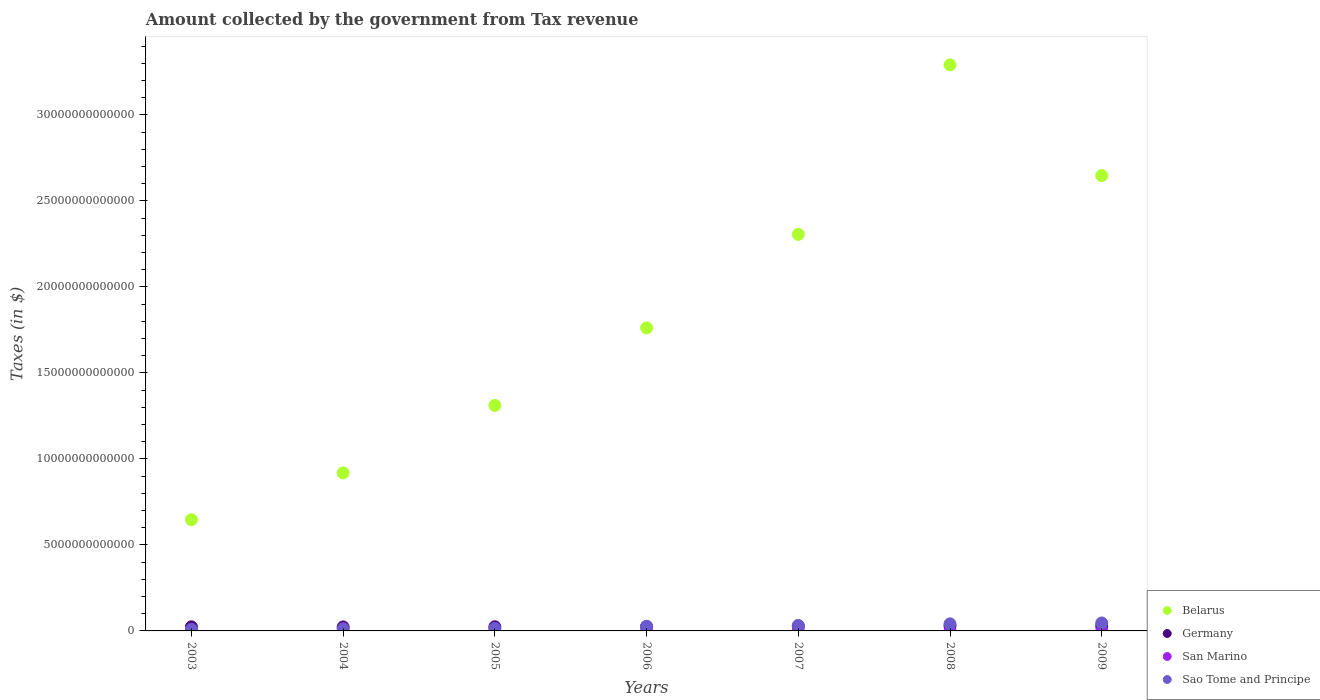How many different coloured dotlines are there?
Make the answer very short. 4. Is the number of dotlines equal to the number of legend labels?
Your response must be concise. Yes. What is the amount collected by the government from tax revenue in Germany in 2009?
Your answer should be compact. 2.82e+11. Across all years, what is the maximum amount collected by the government from tax revenue in San Marino?
Your answer should be very brief. 2.89e+08. Across all years, what is the minimum amount collected by the government from tax revenue in San Marino?
Provide a succinct answer. 2.19e+08. In which year was the amount collected by the government from tax revenue in Germany maximum?
Keep it short and to the point. 2008. What is the total amount collected by the government from tax revenue in Belarus in the graph?
Your response must be concise. 1.29e+14. What is the difference between the amount collected by the government from tax revenue in San Marino in 2004 and that in 2009?
Offer a terse response. -3.11e+07. What is the difference between the amount collected by the government from tax revenue in Belarus in 2004 and the amount collected by the government from tax revenue in San Marino in 2008?
Your answer should be compact. 9.18e+12. What is the average amount collected by the government from tax revenue in Germany per year?
Make the answer very short. 2.59e+11. In the year 2009, what is the difference between the amount collected by the government from tax revenue in Germany and amount collected by the government from tax revenue in Sao Tome and Principe?
Your answer should be very brief. -1.79e+11. In how many years, is the amount collected by the government from tax revenue in Belarus greater than 5000000000000 $?
Make the answer very short. 7. What is the ratio of the amount collected by the government from tax revenue in San Marino in 2007 to that in 2009?
Make the answer very short. 1.12. Is the difference between the amount collected by the government from tax revenue in Germany in 2008 and 2009 greater than the difference between the amount collected by the government from tax revenue in Sao Tome and Principe in 2008 and 2009?
Offer a very short reply. Yes. What is the difference between the highest and the second highest amount collected by the government from tax revenue in Germany?
Offer a very short reply. 3.58e+09. What is the difference between the highest and the lowest amount collected by the government from tax revenue in Sao Tome and Principe?
Provide a succinct answer. 3.66e+11. Is it the case that in every year, the sum of the amount collected by the government from tax revenue in Belarus and amount collected by the government from tax revenue in Sao Tome and Principe  is greater than the amount collected by the government from tax revenue in San Marino?
Your answer should be very brief. Yes. Does the amount collected by the government from tax revenue in San Marino monotonically increase over the years?
Provide a short and direct response. No. Is the amount collected by the government from tax revenue in Belarus strictly greater than the amount collected by the government from tax revenue in Sao Tome and Principe over the years?
Ensure brevity in your answer.  Yes. Is the amount collected by the government from tax revenue in Sao Tome and Principe strictly less than the amount collected by the government from tax revenue in San Marino over the years?
Ensure brevity in your answer.  No. What is the difference between two consecutive major ticks on the Y-axis?
Offer a terse response. 5.00e+12. Are the values on the major ticks of Y-axis written in scientific E-notation?
Make the answer very short. No. Does the graph contain any zero values?
Your answer should be compact. No. How many legend labels are there?
Make the answer very short. 4. What is the title of the graph?
Provide a succinct answer. Amount collected by the government from Tax revenue. What is the label or title of the X-axis?
Provide a short and direct response. Years. What is the label or title of the Y-axis?
Make the answer very short. Taxes (in $). What is the Taxes (in $) of Belarus in 2003?
Your answer should be compact. 6.47e+12. What is the Taxes (in $) of Germany in 2003?
Your answer should be compact. 2.38e+11. What is the Taxes (in $) in San Marino in 2003?
Offer a terse response. 2.19e+08. What is the Taxes (in $) of Sao Tome and Principe in 2003?
Offer a terse response. 9.57e+1. What is the Taxes (in $) in Belarus in 2004?
Provide a short and direct response. 9.18e+12. What is the Taxes (in $) in Germany in 2004?
Your response must be concise. 2.33e+11. What is the Taxes (in $) in San Marino in 2004?
Your response must be concise. 2.20e+08. What is the Taxes (in $) in Sao Tome and Principe in 2004?
Your answer should be very brief. 1.30e+11. What is the Taxes (in $) in Belarus in 2005?
Ensure brevity in your answer.  1.31e+13. What is the Taxes (in $) of Germany in 2005?
Your response must be concise. 2.40e+11. What is the Taxes (in $) in San Marino in 2005?
Give a very brief answer. 2.43e+08. What is the Taxes (in $) in Sao Tome and Principe in 2005?
Offer a terse response. 1.46e+11. What is the Taxes (in $) of Belarus in 2006?
Your answer should be very brief. 1.76e+13. What is the Taxes (in $) of Germany in 2006?
Ensure brevity in your answer.  2.55e+11. What is the Taxes (in $) in San Marino in 2006?
Offer a very short reply. 2.62e+08. What is the Taxes (in $) in Sao Tome and Principe in 2006?
Your answer should be very brief. 2.67e+11. What is the Taxes (in $) in Belarus in 2007?
Offer a terse response. 2.31e+13. What is the Taxes (in $) in Germany in 2007?
Make the answer very short. 2.79e+11. What is the Taxes (in $) in San Marino in 2007?
Make the answer very short. 2.82e+08. What is the Taxes (in $) of Sao Tome and Principe in 2007?
Give a very brief answer. 3.20e+11. What is the Taxes (in $) in Belarus in 2008?
Offer a terse response. 3.29e+13. What is the Taxes (in $) in Germany in 2008?
Your answer should be compact. 2.86e+11. What is the Taxes (in $) in San Marino in 2008?
Provide a succinct answer. 2.89e+08. What is the Taxes (in $) in Sao Tome and Principe in 2008?
Provide a succinct answer. 4.11e+11. What is the Taxes (in $) in Belarus in 2009?
Keep it short and to the point. 2.65e+13. What is the Taxes (in $) of Germany in 2009?
Your response must be concise. 2.82e+11. What is the Taxes (in $) in San Marino in 2009?
Ensure brevity in your answer.  2.51e+08. What is the Taxes (in $) of Sao Tome and Principe in 2009?
Give a very brief answer. 4.62e+11. Across all years, what is the maximum Taxes (in $) in Belarus?
Your answer should be very brief. 3.29e+13. Across all years, what is the maximum Taxes (in $) of Germany?
Your answer should be compact. 2.86e+11. Across all years, what is the maximum Taxes (in $) of San Marino?
Offer a terse response. 2.89e+08. Across all years, what is the maximum Taxes (in $) in Sao Tome and Principe?
Give a very brief answer. 4.62e+11. Across all years, what is the minimum Taxes (in $) of Belarus?
Your answer should be compact. 6.47e+12. Across all years, what is the minimum Taxes (in $) in Germany?
Keep it short and to the point. 2.33e+11. Across all years, what is the minimum Taxes (in $) of San Marino?
Make the answer very short. 2.19e+08. Across all years, what is the minimum Taxes (in $) of Sao Tome and Principe?
Keep it short and to the point. 9.57e+1. What is the total Taxes (in $) of Belarus in the graph?
Offer a very short reply. 1.29e+14. What is the total Taxes (in $) in Germany in the graph?
Give a very brief answer. 1.81e+12. What is the total Taxes (in $) of San Marino in the graph?
Your response must be concise. 1.76e+09. What is the total Taxes (in $) in Sao Tome and Principe in the graph?
Offer a very short reply. 1.83e+12. What is the difference between the Taxes (in $) of Belarus in 2003 and that in 2004?
Your response must be concise. -2.72e+12. What is the difference between the Taxes (in $) of Germany in 2003 and that in 2004?
Ensure brevity in your answer.  5.22e+09. What is the difference between the Taxes (in $) of San Marino in 2003 and that in 2004?
Give a very brief answer. -1.02e+06. What is the difference between the Taxes (in $) of Sao Tome and Principe in 2003 and that in 2004?
Keep it short and to the point. -3.42e+1. What is the difference between the Taxes (in $) of Belarus in 2003 and that in 2005?
Give a very brief answer. -6.64e+12. What is the difference between the Taxes (in $) in Germany in 2003 and that in 2005?
Your response must be concise. -2.44e+09. What is the difference between the Taxes (in $) of San Marino in 2003 and that in 2005?
Make the answer very short. -2.46e+07. What is the difference between the Taxes (in $) in Sao Tome and Principe in 2003 and that in 2005?
Provide a short and direct response. -5.02e+1. What is the difference between the Taxes (in $) in Belarus in 2003 and that in 2006?
Your response must be concise. -1.11e+13. What is the difference between the Taxes (in $) of Germany in 2003 and that in 2006?
Keep it short and to the point. -1.70e+1. What is the difference between the Taxes (in $) of San Marino in 2003 and that in 2006?
Your response must be concise. -4.34e+07. What is the difference between the Taxes (in $) of Sao Tome and Principe in 2003 and that in 2006?
Ensure brevity in your answer.  -1.71e+11. What is the difference between the Taxes (in $) of Belarus in 2003 and that in 2007?
Provide a short and direct response. -1.66e+13. What is the difference between the Taxes (in $) of Germany in 2003 and that in 2007?
Your response must be concise. -4.10e+1. What is the difference between the Taxes (in $) in San Marino in 2003 and that in 2007?
Ensure brevity in your answer.  -6.31e+07. What is the difference between the Taxes (in $) of Sao Tome and Principe in 2003 and that in 2007?
Give a very brief answer. -2.24e+11. What is the difference between the Taxes (in $) in Belarus in 2003 and that in 2008?
Offer a terse response. -2.64e+13. What is the difference between the Taxes (in $) of Germany in 2003 and that in 2008?
Offer a terse response. -4.78e+1. What is the difference between the Taxes (in $) in San Marino in 2003 and that in 2008?
Your answer should be very brief. -7.02e+07. What is the difference between the Taxes (in $) in Sao Tome and Principe in 2003 and that in 2008?
Give a very brief answer. -3.15e+11. What is the difference between the Taxes (in $) in Belarus in 2003 and that in 2009?
Make the answer very short. -2.00e+13. What is the difference between the Taxes (in $) in Germany in 2003 and that in 2009?
Your answer should be very brief. -4.42e+1. What is the difference between the Taxes (in $) in San Marino in 2003 and that in 2009?
Offer a terse response. -3.21e+07. What is the difference between the Taxes (in $) in Sao Tome and Principe in 2003 and that in 2009?
Provide a short and direct response. -3.66e+11. What is the difference between the Taxes (in $) in Belarus in 2004 and that in 2005?
Offer a very short reply. -3.93e+12. What is the difference between the Taxes (in $) in Germany in 2004 and that in 2005?
Your answer should be compact. -7.66e+09. What is the difference between the Taxes (in $) of San Marino in 2004 and that in 2005?
Your response must be concise. -2.36e+07. What is the difference between the Taxes (in $) in Sao Tome and Principe in 2004 and that in 2005?
Provide a succinct answer. -1.59e+1. What is the difference between the Taxes (in $) of Belarus in 2004 and that in 2006?
Your answer should be compact. -8.43e+12. What is the difference between the Taxes (in $) in Germany in 2004 and that in 2006?
Your answer should be compact. -2.22e+1. What is the difference between the Taxes (in $) in San Marino in 2004 and that in 2006?
Ensure brevity in your answer.  -4.23e+07. What is the difference between the Taxes (in $) of Sao Tome and Principe in 2004 and that in 2006?
Your response must be concise. -1.37e+11. What is the difference between the Taxes (in $) in Belarus in 2004 and that in 2007?
Keep it short and to the point. -1.39e+13. What is the difference between the Taxes (in $) of Germany in 2004 and that in 2007?
Keep it short and to the point. -4.62e+1. What is the difference between the Taxes (in $) of San Marino in 2004 and that in 2007?
Give a very brief answer. -6.21e+07. What is the difference between the Taxes (in $) in Sao Tome and Principe in 2004 and that in 2007?
Your response must be concise. -1.90e+11. What is the difference between the Taxes (in $) of Belarus in 2004 and that in 2008?
Ensure brevity in your answer.  -2.37e+13. What is the difference between the Taxes (in $) in Germany in 2004 and that in 2008?
Offer a terse response. -5.30e+1. What is the difference between the Taxes (in $) in San Marino in 2004 and that in 2008?
Keep it short and to the point. -6.91e+07. What is the difference between the Taxes (in $) in Sao Tome and Principe in 2004 and that in 2008?
Provide a short and direct response. -2.81e+11. What is the difference between the Taxes (in $) of Belarus in 2004 and that in 2009?
Offer a terse response. -1.73e+13. What is the difference between the Taxes (in $) of Germany in 2004 and that in 2009?
Provide a short and direct response. -4.94e+1. What is the difference between the Taxes (in $) in San Marino in 2004 and that in 2009?
Provide a succinct answer. -3.11e+07. What is the difference between the Taxes (in $) of Sao Tome and Principe in 2004 and that in 2009?
Offer a very short reply. -3.32e+11. What is the difference between the Taxes (in $) of Belarus in 2005 and that in 2006?
Ensure brevity in your answer.  -4.50e+12. What is the difference between the Taxes (in $) in Germany in 2005 and that in 2006?
Keep it short and to the point. -1.46e+1. What is the difference between the Taxes (in $) of San Marino in 2005 and that in 2006?
Ensure brevity in your answer.  -1.88e+07. What is the difference between the Taxes (in $) in Sao Tome and Principe in 2005 and that in 2006?
Offer a terse response. -1.21e+11. What is the difference between the Taxes (in $) in Belarus in 2005 and that in 2007?
Offer a terse response. -9.94e+12. What is the difference between the Taxes (in $) of Germany in 2005 and that in 2007?
Provide a short and direct response. -3.85e+1. What is the difference between the Taxes (in $) in San Marino in 2005 and that in 2007?
Offer a very short reply. -3.85e+07. What is the difference between the Taxes (in $) in Sao Tome and Principe in 2005 and that in 2007?
Make the answer very short. -1.74e+11. What is the difference between the Taxes (in $) in Belarus in 2005 and that in 2008?
Your answer should be compact. -1.98e+13. What is the difference between the Taxes (in $) in Germany in 2005 and that in 2008?
Offer a very short reply. -4.54e+1. What is the difference between the Taxes (in $) of San Marino in 2005 and that in 2008?
Your answer should be very brief. -4.56e+07. What is the difference between the Taxes (in $) of Sao Tome and Principe in 2005 and that in 2008?
Your answer should be very brief. -2.65e+11. What is the difference between the Taxes (in $) of Belarus in 2005 and that in 2009?
Offer a very short reply. -1.34e+13. What is the difference between the Taxes (in $) in Germany in 2005 and that in 2009?
Offer a very short reply. -4.18e+1. What is the difference between the Taxes (in $) of San Marino in 2005 and that in 2009?
Keep it short and to the point. -7.51e+06. What is the difference between the Taxes (in $) of Sao Tome and Principe in 2005 and that in 2009?
Your response must be concise. -3.16e+11. What is the difference between the Taxes (in $) of Belarus in 2006 and that in 2007?
Offer a very short reply. -5.44e+12. What is the difference between the Taxes (in $) in Germany in 2006 and that in 2007?
Provide a short and direct response. -2.40e+1. What is the difference between the Taxes (in $) of San Marino in 2006 and that in 2007?
Make the answer very short. -1.97e+07. What is the difference between the Taxes (in $) in Sao Tome and Principe in 2006 and that in 2007?
Keep it short and to the point. -5.32e+1. What is the difference between the Taxes (in $) of Belarus in 2006 and that in 2008?
Your answer should be very brief. -1.53e+13. What is the difference between the Taxes (in $) of Germany in 2006 and that in 2008?
Provide a succinct answer. -3.08e+1. What is the difference between the Taxes (in $) in San Marino in 2006 and that in 2008?
Offer a very short reply. -2.68e+07. What is the difference between the Taxes (in $) of Sao Tome and Principe in 2006 and that in 2008?
Your response must be concise. -1.44e+11. What is the difference between the Taxes (in $) of Belarus in 2006 and that in 2009?
Offer a very short reply. -8.86e+12. What is the difference between the Taxes (in $) of Germany in 2006 and that in 2009?
Your response must be concise. -2.72e+1. What is the difference between the Taxes (in $) in San Marino in 2006 and that in 2009?
Your answer should be compact. 1.13e+07. What is the difference between the Taxes (in $) in Sao Tome and Principe in 2006 and that in 2009?
Offer a very short reply. -1.95e+11. What is the difference between the Taxes (in $) in Belarus in 2007 and that in 2008?
Make the answer very short. -9.85e+12. What is the difference between the Taxes (in $) in Germany in 2007 and that in 2008?
Your answer should be compact. -6.81e+09. What is the difference between the Taxes (in $) of San Marino in 2007 and that in 2008?
Provide a short and direct response. -7.06e+06. What is the difference between the Taxes (in $) of Sao Tome and Principe in 2007 and that in 2008?
Offer a very short reply. -9.12e+1. What is the difference between the Taxes (in $) of Belarus in 2007 and that in 2009?
Keep it short and to the point. -3.42e+12. What is the difference between the Taxes (in $) in Germany in 2007 and that in 2009?
Make the answer very short. -3.23e+09. What is the difference between the Taxes (in $) in San Marino in 2007 and that in 2009?
Keep it short and to the point. 3.10e+07. What is the difference between the Taxes (in $) in Sao Tome and Principe in 2007 and that in 2009?
Ensure brevity in your answer.  -1.42e+11. What is the difference between the Taxes (in $) of Belarus in 2008 and that in 2009?
Your answer should be very brief. 6.44e+12. What is the difference between the Taxes (in $) in Germany in 2008 and that in 2009?
Provide a short and direct response. 3.58e+09. What is the difference between the Taxes (in $) in San Marino in 2008 and that in 2009?
Provide a short and direct response. 3.80e+07. What is the difference between the Taxes (in $) of Sao Tome and Principe in 2008 and that in 2009?
Give a very brief answer. -5.06e+1. What is the difference between the Taxes (in $) of Belarus in 2003 and the Taxes (in $) of Germany in 2004?
Offer a terse response. 6.23e+12. What is the difference between the Taxes (in $) of Belarus in 2003 and the Taxes (in $) of San Marino in 2004?
Your response must be concise. 6.47e+12. What is the difference between the Taxes (in $) of Belarus in 2003 and the Taxes (in $) of Sao Tome and Principe in 2004?
Make the answer very short. 6.34e+12. What is the difference between the Taxes (in $) of Germany in 2003 and the Taxes (in $) of San Marino in 2004?
Your response must be concise. 2.38e+11. What is the difference between the Taxes (in $) in Germany in 2003 and the Taxes (in $) in Sao Tome and Principe in 2004?
Offer a terse response. 1.08e+11. What is the difference between the Taxes (in $) of San Marino in 2003 and the Taxes (in $) of Sao Tome and Principe in 2004?
Keep it short and to the point. -1.30e+11. What is the difference between the Taxes (in $) in Belarus in 2003 and the Taxes (in $) in Germany in 2005?
Give a very brief answer. 6.23e+12. What is the difference between the Taxes (in $) in Belarus in 2003 and the Taxes (in $) in San Marino in 2005?
Your answer should be very brief. 6.47e+12. What is the difference between the Taxes (in $) of Belarus in 2003 and the Taxes (in $) of Sao Tome and Principe in 2005?
Give a very brief answer. 6.32e+12. What is the difference between the Taxes (in $) of Germany in 2003 and the Taxes (in $) of San Marino in 2005?
Provide a short and direct response. 2.38e+11. What is the difference between the Taxes (in $) in Germany in 2003 and the Taxes (in $) in Sao Tome and Principe in 2005?
Your response must be concise. 9.22e+1. What is the difference between the Taxes (in $) in San Marino in 2003 and the Taxes (in $) in Sao Tome and Principe in 2005?
Offer a very short reply. -1.46e+11. What is the difference between the Taxes (in $) in Belarus in 2003 and the Taxes (in $) in Germany in 2006?
Make the answer very short. 6.21e+12. What is the difference between the Taxes (in $) of Belarus in 2003 and the Taxes (in $) of San Marino in 2006?
Provide a short and direct response. 6.47e+12. What is the difference between the Taxes (in $) of Belarus in 2003 and the Taxes (in $) of Sao Tome and Principe in 2006?
Offer a very short reply. 6.20e+12. What is the difference between the Taxes (in $) in Germany in 2003 and the Taxes (in $) in San Marino in 2006?
Provide a succinct answer. 2.38e+11. What is the difference between the Taxes (in $) in Germany in 2003 and the Taxes (in $) in Sao Tome and Principe in 2006?
Your answer should be compact. -2.86e+1. What is the difference between the Taxes (in $) in San Marino in 2003 and the Taxes (in $) in Sao Tome and Principe in 2006?
Ensure brevity in your answer.  -2.66e+11. What is the difference between the Taxes (in $) of Belarus in 2003 and the Taxes (in $) of Germany in 2007?
Give a very brief answer. 6.19e+12. What is the difference between the Taxes (in $) in Belarus in 2003 and the Taxes (in $) in San Marino in 2007?
Provide a succinct answer. 6.47e+12. What is the difference between the Taxes (in $) of Belarus in 2003 and the Taxes (in $) of Sao Tome and Principe in 2007?
Your response must be concise. 6.15e+12. What is the difference between the Taxes (in $) of Germany in 2003 and the Taxes (in $) of San Marino in 2007?
Your answer should be compact. 2.38e+11. What is the difference between the Taxes (in $) in Germany in 2003 and the Taxes (in $) in Sao Tome and Principe in 2007?
Provide a short and direct response. -8.18e+1. What is the difference between the Taxes (in $) in San Marino in 2003 and the Taxes (in $) in Sao Tome and Principe in 2007?
Provide a succinct answer. -3.20e+11. What is the difference between the Taxes (in $) of Belarus in 2003 and the Taxes (in $) of Germany in 2008?
Provide a short and direct response. 6.18e+12. What is the difference between the Taxes (in $) of Belarus in 2003 and the Taxes (in $) of San Marino in 2008?
Your answer should be compact. 6.47e+12. What is the difference between the Taxes (in $) of Belarus in 2003 and the Taxes (in $) of Sao Tome and Principe in 2008?
Your response must be concise. 6.06e+12. What is the difference between the Taxes (in $) of Germany in 2003 and the Taxes (in $) of San Marino in 2008?
Your answer should be compact. 2.38e+11. What is the difference between the Taxes (in $) in Germany in 2003 and the Taxes (in $) in Sao Tome and Principe in 2008?
Keep it short and to the point. -1.73e+11. What is the difference between the Taxes (in $) of San Marino in 2003 and the Taxes (in $) of Sao Tome and Principe in 2008?
Keep it short and to the point. -4.11e+11. What is the difference between the Taxes (in $) of Belarus in 2003 and the Taxes (in $) of Germany in 2009?
Offer a terse response. 6.19e+12. What is the difference between the Taxes (in $) in Belarus in 2003 and the Taxes (in $) in San Marino in 2009?
Give a very brief answer. 6.47e+12. What is the difference between the Taxes (in $) of Belarus in 2003 and the Taxes (in $) of Sao Tome and Principe in 2009?
Offer a terse response. 6.01e+12. What is the difference between the Taxes (in $) in Germany in 2003 and the Taxes (in $) in San Marino in 2009?
Provide a short and direct response. 2.38e+11. What is the difference between the Taxes (in $) of Germany in 2003 and the Taxes (in $) of Sao Tome and Principe in 2009?
Provide a succinct answer. -2.24e+11. What is the difference between the Taxes (in $) of San Marino in 2003 and the Taxes (in $) of Sao Tome and Principe in 2009?
Keep it short and to the point. -4.61e+11. What is the difference between the Taxes (in $) in Belarus in 2004 and the Taxes (in $) in Germany in 2005?
Offer a very short reply. 8.94e+12. What is the difference between the Taxes (in $) in Belarus in 2004 and the Taxes (in $) in San Marino in 2005?
Provide a short and direct response. 9.18e+12. What is the difference between the Taxes (in $) in Belarus in 2004 and the Taxes (in $) in Sao Tome and Principe in 2005?
Your answer should be very brief. 9.04e+12. What is the difference between the Taxes (in $) of Germany in 2004 and the Taxes (in $) of San Marino in 2005?
Your response must be concise. 2.33e+11. What is the difference between the Taxes (in $) of Germany in 2004 and the Taxes (in $) of Sao Tome and Principe in 2005?
Your response must be concise. 8.69e+1. What is the difference between the Taxes (in $) in San Marino in 2004 and the Taxes (in $) in Sao Tome and Principe in 2005?
Ensure brevity in your answer.  -1.46e+11. What is the difference between the Taxes (in $) in Belarus in 2004 and the Taxes (in $) in Germany in 2006?
Your answer should be compact. 8.93e+12. What is the difference between the Taxes (in $) of Belarus in 2004 and the Taxes (in $) of San Marino in 2006?
Keep it short and to the point. 9.18e+12. What is the difference between the Taxes (in $) of Belarus in 2004 and the Taxes (in $) of Sao Tome and Principe in 2006?
Make the answer very short. 8.92e+12. What is the difference between the Taxes (in $) in Germany in 2004 and the Taxes (in $) in San Marino in 2006?
Offer a terse response. 2.33e+11. What is the difference between the Taxes (in $) in Germany in 2004 and the Taxes (in $) in Sao Tome and Principe in 2006?
Offer a terse response. -3.38e+1. What is the difference between the Taxes (in $) in San Marino in 2004 and the Taxes (in $) in Sao Tome and Principe in 2006?
Your answer should be compact. -2.66e+11. What is the difference between the Taxes (in $) in Belarus in 2004 and the Taxes (in $) in Germany in 2007?
Give a very brief answer. 8.91e+12. What is the difference between the Taxes (in $) in Belarus in 2004 and the Taxes (in $) in San Marino in 2007?
Your answer should be very brief. 9.18e+12. What is the difference between the Taxes (in $) of Belarus in 2004 and the Taxes (in $) of Sao Tome and Principe in 2007?
Your answer should be very brief. 8.86e+12. What is the difference between the Taxes (in $) of Germany in 2004 and the Taxes (in $) of San Marino in 2007?
Make the answer very short. 2.33e+11. What is the difference between the Taxes (in $) in Germany in 2004 and the Taxes (in $) in Sao Tome and Principe in 2007?
Your response must be concise. -8.70e+1. What is the difference between the Taxes (in $) in San Marino in 2004 and the Taxes (in $) in Sao Tome and Principe in 2007?
Offer a terse response. -3.20e+11. What is the difference between the Taxes (in $) in Belarus in 2004 and the Taxes (in $) in Germany in 2008?
Ensure brevity in your answer.  8.90e+12. What is the difference between the Taxes (in $) in Belarus in 2004 and the Taxes (in $) in San Marino in 2008?
Ensure brevity in your answer.  9.18e+12. What is the difference between the Taxes (in $) in Belarus in 2004 and the Taxes (in $) in Sao Tome and Principe in 2008?
Offer a terse response. 8.77e+12. What is the difference between the Taxes (in $) of Germany in 2004 and the Taxes (in $) of San Marino in 2008?
Provide a succinct answer. 2.33e+11. What is the difference between the Taxes (in $) in Germany in 2004 and the Taxes (in $) in Sao Tome and Principe in 2008?
Give a very brief answer. -1.78e+11. What is the difference between the Taxes (in $) in San Marino in 2004 and the Taxes (in $) in Sao Tome and Principe in 2008?
Provide a succinct answer. -4.11e+11. What is the difference between the Taxes (in $) of Belarus in 2004 and the Taxes (in $) of Germany in 2009?
Keep it short and to the point. 8.90e+12. What is the difference between the Taxes (in $) of Belarus in 2004 and the Taxes (in $) of San Marino in 2009?
Offer a terse response. 9.18e+12. What is the difference between the Taxes (in $) of Belarus in 2004 and the Taxes (in $) of Sao Tome and Principe in 2009?
Offer a very short reply. 8.72e+12. What is the difference between the Taxes (in $) of Germany in 2004 and the Taxes (in $) of San Marino in 2009?
Your answer should be very brief. 2.33e+11. What is the difference between the Taxes (in $) of Germany in 2004 and the Taxes (in $) of Sao Tome and Principe in 2009?
Ensure brevity in your answer.  -2.29e+11. What is the difference between the Taxes (in $) of San Marino in 2004 and the Taxes (in $) of Sao Tome and Principe in 2009?
Ensure brevity in your answer.  -4.61e+11. What is the difference between the Taxes (in $) of Belarus in 2005 and the Taxes (in $) of Germany in 2006?
Provide a succinct answer. 1.29e+13. What is the difference between the Taxes (in $) in Belarus in 2005 and the Taxes (in $) in San Marino in 2006?
Offer a very short reply. 1.31e+13. What is the difference between the Taxes (in $) of Belarus in 2005 and the Taxes (in $) of Sao Tome and Principe in 2006?
Give a very brief answer. 1.28e+13. What is the difference between the Taxes (in $) of Germany in 2005 and the Taxes (in $) of San Marino in 2006?
Keep it short and to the point. 2.40e+11. What is the difference between the Taxes (in $) of Germany in 2005 and the Taxes (in $) of Sao Tome and Principe in 2006?
Provide a short and direct response. -2.62e+1. What is the difference between the Taxes (in $) of San Marino in 2005 and the Taxes (in $) of Sao Tome and Principe in 2006?
Your answer should be compact. -2.66e+11. What is the difference between the Taxes (in $) of Belarus in 2005 and the Taxes (in $) of Germany in 2007?
Your response must be concise. 1.28e+13. What is the difference between the Taxes (in $) of Belarus in 2005 and the Taxes (in $) of San Marino in 2007?
Give a very brief answer. 1.31e+13. What is the difference between the Taxes (in $) of Belarus in 2005 and the Taxes (in $) of Sao Tome and Principe in 2007?
Provide a succinct answer. 1.28e+13. What is the difference between the Taxes (in $) in Germany in 2005 and the Taxes (in $) in San Marino in 2007?
Keep it short and to the point. 2.40e+11. What is the difference between the Taxes (in $) in Germany in 2005 and the Taxes (in $) in Sao Tome and Principe in 2007?
Make the answer very short. -7.93e+1. What is the difference between the Taxes (in $) of San Marino in 2005 and the Taxes (in $) of Sao Tome and Principe in 2007?
Offer a very short reply. -3.20e+11. What is the difference between the Taxes (in $) in Belarus in 2005 and the Taxes (in $) in Germany in 2008?
Ensure brevity in your answer.  1.28e+13. What is the difference between the Taxes (in $) of Belarus in 2005 and the Taxes (in $) of San Marino in 2008?
Keep it short and to the point. 1.31e+13. What is the difference between the Taxes (in $) of Belarus in 2005 and the Taxes (in $) of Sao Tome and Principe in 2008?
Your response must be concise. 1.27e+13. What is the difference between the Taxes (in $) in Germany in 2005 and the Taxes (in $) in San Marino in 2008?
Make the answer very short. 2.40e+11. What is the difference between the Taxes (in $) in Germany in 2005 and the Taxes (in $) in Sao Tome and Principe in 2008?
Your answer should be very brief. -1.71e+11. What is the difference between the Taxes (in $) in San Marino in 2005 and the Taxes (in $) in Sao Tome and Principe in 2008?
Provide a short and direct response. -4.11e+11. What is the difference between the Taxes (in $) of Belarus in 2005 and the Taxes (in $) of Germany in 2009?
Provide a short and direct response. 1.28e+13. What is the difference between the Taxes (in $) of Belarus in 2005 and the Taxes (in $) of San Marino in 2009?
Offer a very short reply. 1.31e+13. What is the difference between the Taxes (in $) in Belarus in 2005 and the Taxes (in $) in Sao Tome and Principe in 2009?
Ensure brevity in your answer.  1.26e+13. What is the difference between the Taxes (in $) of Germany in 2005 and the Taxes (in $) of San Marino in 2009?
Give a very brief answer. 2.40e+11. What is the difference between the Taxes (in $) of Germany in 2005 and the Taxes (in $) of Sao Tome and Principe in 2009?
Your answer should be very brief. -2.21e+11. What is the difference between the Taxes (in $) of San Marino in 2005 and the Taxes (in $) of Sao Tome and Principe in 2009?
Your response must be concise. -4.61e+11. What is the difference between the Taxes (in $) in Belarus in 2006 and the Taxes (in $) in Germany in 2007?
Ensure brevity in your answer.  1.73e+13. What is the difference between the Taxes (in $) in Belarus in 2006 and the Taxes (in $) in San Marino in 2007?
Ensure brevity in your answer.  1.76e+13. What is the difference between the Taxes (in $) of Belarus in 2006 and the Taxes (in $) of Sao Tome and Principe in 2007?
Offer a terse response. 1.73e+13. What is the difference between the Taxes (in $) in Germany in 2006 and the Taxes (in $) in San Marino in 2007?
Your answer should be very brief. 2.55e+11. What is the difference between the Taxes (in $) in Germany in 2006 and the Taxes (in $) in Sao Tome and Principe in 2007?
Your answer should be very brief. -6.47e+1. What is the difference between the Taxes (in $) of San Marino in 2006 and the Taxes (in $) of Sao Tome and Principe in 2007?
Your answer should be very brief. -3.20e+11. What is the difference between the Taxes (in $) of Belarus in 2006 and the Taxes (in $) of Germany in 2008?
Your answer should be compact. 1.73e+13. What is the difference between the Taxes (in $) of Belarus in 2006 and the Taxes (in $) of San Marino in 2008?
Your answer should be compact. 1.76e+13. What is the difference between the Taxes (in $) of Belarus in 2006 and the Taxes (in $) of Sao Tome and Principe in 2008?
Offer a terse response. 1.72e+13. What is the difference between the Taxes (in $) of Germany in 2006 and the Taxes (in $) of San Marino in 2008?
Your answer should be compact. 2.55e+11. What is the difference between the Taxes (in $) of Germany in 2006 and the Taxes (in $) of Sao Tome and Principe in 2008?
Offer a terse response. -1.56e+11. What is the difference between the Taxes (in $) in San Marino in 2006 and the Taxes (in $) in Sao Tome and Principe in 2008?
Offer a very short reply. -4.11e+11. What is the difference between the Taxes (in $) of Belarus in 2006 and the Taxes (in $) of Germany in 2009?
Your answer should be very brief. 1.73e+13. What is the difference between the Taxes (in $) of Belarus in 2006 and the Taxes (in $) of San Marino in 2009?
Your answer should be very brief. 1.76e+13. What is the difference between the Taxes (in $) in Belarus in 2006 and the Taxes (in $) in Sao Tome and Principe in 2009?
Your response must be concise. 1.72e+13. What is the difference between the Taxes (in $) in Germany in 2006 and the Taxes (in $) in San Marino in 2009?
Make the answer very short. 2.55e+11. What is the difference between the Taxes (in $) in Germany in 2006 and the Taxes (in $) in Sao Tome and Principe in 2009?
Your answer should be compact. -2.07e+11. What is the difference between the Taxes (in $) in San Marino in 2006 and the Taxes (in $) in Sao Tome and Principe in 2009?
Keep it short and to the point. -4.61e+11. What is the difference between the Taxes (in $) in Belarus in 2007 and the Taxes (in $) in Germany in 2008?
Keep it short and to the point. 2.28e+13. What is the difference between the Taxes (in $) of Belarus in 2007 and the Taxes (in $) of San Marino in 2008?
Provide a short and direct response. 2.31e+13. What is the difference between the Taxes (in $) of Belarus in 2007 and the Taxes (in $) of Sao Tome and Principe in 2008?
Ensure brevity in your answer.  2.26e+13. What is the difference between the Taxes (in $) of Germany in 2007 and the Taxes (in $) of San Marino in 2008?
Your answer should be compact. 2.79e+11. What is the difference between the Taxes (in $) in Germany in 2007 and the Taxes (in $) in Sao Tome and Principe in 2008?
Ensure brevity in your answer.  -1.32e+11. What is the difference between the Taxes (in $) in San Marino in 2007 and the Taxes (in $) in Sao Tome and Principe in 2008?
Ensure brevity in your answer.  -4.11e+11. What is the difference between the Taxes (in $) of Belarus in 2007 and the Taxes (in $) of Germany in 2009?
Give a very brief answer. 2.28e+13. What is the difference between the Taxes (in $) of Belarus in 2007 and the Taxes (in $) of San Marino in 2009?
Make the answer very short. 2.31e+13. What is the difference between the Taxes (in $) in Belarus in 2007 and the Taxes (in $) in Sao Tome and Principe in 2009?
Offer a very short reply. 2.26e+13. What is the difference between the Taxes (in $) in Germany in 2007 and the Taxes (in $) in San Marino in 2009?
Give a very brief answer. 2.79e+11. What is the difference between the Taxes (in $) of Germany in 2007 and the Taxes (in $) of Sao Tome and Principe in 2009?
Your answer should be compact. -1.83e+11. What is the difference between the Taxes (in $) in San Marino in 2007 and the Taxes (in $) in Sao Tome and Principe in 2009?
Your answer should be very brief. -4.61e+11. What is the difference between the Taxes (in $) of Belarus in 2008 and the Taxes (in $) of Germany in 2009?
Offer a terse response. 3.26e+13. What is the difference between the Taxes (in $) of Belarus in 2008 and the Taxes (in $) of San Marino in 2009?
Keep it short and to the point. 3.29e+13. What is the difference between the Taxes (in $) of Belarus in 2008 and the Taxes (in $) of Sao Tome and Principe in 2009?
Make the answer very short. 3.24e+13. What is the difference between the Taxes (in $) of Germany in 2008 and the Taxes (in $) of San Marino in 2009?
Provide a succinct answer. 2.86e+11. What is the difference between the Taxes (in $) of Germany in 2008 and the Taxes (in $) of Sao Tome and Principe in 2009?
Your answer should be compact. -1.76e+11. What is the difference between the Taxes (in $) in San Marino in 2008 and the Taxes (in $) in Sao Tome and Principe in 2009?
Give a very brief answer. -4.61e+11. What is the average Taxes (in $) of Belarus per year?
Offer a terse response. 1.84e+13. What is the average Taxes (in $) of Germany per year?
Your answer should be compact. 2.59e+11. What is the average Taxes (in $) in San Marino per year?
Your answer should be compact. 2.52e+08. What is the average Taxes (in $) in Sao Tome and Principe per year?
Give a very brief answer. 2.61e+11. In the year 2003, what is the difference between the Taxes (in $) in Belarus and Taxes (in $) in Germany?
Keep it short and to the point. 6.23e+12. In the year 2003, what is the difference between the Taxes (in $) in Belarus and Taxes (in $) in San Marino?
Your answer should be compact. 6.47e+12. In the year 2003, what is the difference between the Taxes (in $) of Belarus and Taxes (in $) of Sao Tome and Principe?
Provide a succinct answer. 6.37e+12. In the year 2003, what is the difference between the Taxes (in $) of Germany and Taxes (in $) of San Marino?
Your response must be concise. 2.38e+11. In the year 2003, what is the difference between the Taxes (in $) of Germany and Taxes (in $) of Sao Tome and Principe?
Provide a succinct answer. 1.42e+11. In the year 2003, what is the difference between the Taxes (in $) in San Marino and Taxes (in $) in Sao Tome and Principe?
Provide a succinct answer. -9.55e+1. In the year 2004, what is the difference between the Taxes (in $) in Belarus and Taxes (in $) in Germany?
Offer a terse response. 8.95e+12. In the year 2004, what is the difference between the Taxes (in $) of Belarus and Taxes (in $) of San Marino?
Ensure brevity in your answer.  9.18e+12. In the year 2004, what is the difference between the Taxes (in $) in Belarus and Taxes (in $) in Sao Tome and Principe?
Your answer should be very brief. 9.05e+12. In the year 2004, what is the difference between the Taxes (in $) in Germany and Taxes (in $) in San Marino?
Offer a very short reply. 2.33e+11. In the year 2004, what is the difference between the Taxes (in $) in Germany and Taxes (in $) in Sao Tome and Principe?
Offer a very short reply. 1.03e+11. In the year 2004, what is the difference between the Taxes (in $) of San Marino and Taxes (in $) of Sao Tome and Principe?
Provide a succinct answer. -1.30e+11. In the year 2005, what is the difference between the Taxes (in $) in Belarus and Taxes (in $) in Germany?
Provide a short and direct response. 1.29e+13. In the year 2005, what is the difference between the Taxes (in $) in Belarus and Taxes (in $) in San Marino?
Your response must be concise. 1.31e+13. In the year 2005, what is the difference between the Taxes (in $) of Belarus and Taxes (in $) of Sao Tome and Principe?
Your answer should be very brief. 1.30e+13. In the year 2005, what is the difference between the Taxes (in $) in Germany and Taxes (in $) in San Marino?
Give a very brief answer. 2.40e+11. In the year 2005, what is the difference between the Taxes (in $) of Germany and Taxes (in $) of Sao Tome and Principe?
Keep it short and to the point. 9.46e+1. In the year 2005, what is the difference between the Taxes (in $) in San Marino and Taxes (in $) in Sao Tome and Principe?
Keep it short and to the point. -1.46e+11. In the year 2006, what is the difference between the Taxes (in $) in Belarus and Taxes (in $) in Germany?
Give a very brief answer. 1.74e+13. In the year 2006, what is the difference between the Taxes (in $) of Belarus and Taxes (in $) of San Marino?
Your answer should be compact. 1.76e+13. In the year 2006, what is the difference between the Taxes (in $) of Belarus and Taxes (in $) of Sao Tome and Principe?
Give a very brief answer. 1.73e+13. In the year 2006, what is the difference between the Taxes (in $) in Germany and Taxes (in $) in San Marino?
Offer a very short reply. 2.55e+11. In the year 2006, what is the difference between the Taxes (in $) of Germany and Taxes (in $) of Sao Tome and Principe?
Offer a very short reply. -1.16e+1. In the year 2006, what is the difference between the Taxes (in $) of San Marino and Taxes (in $) of Sao Tome and Principe?
Provide a succinct answer. -2.66e+11. In the year 2007, what is the difference between the Taxes (in $) in Belarus and Taxes (in $) in Germany?
Offer a terse response. 2.28e+13. In the year 2007, what is the difference between the Taxes (in $) in Belarus and Taxes (in $) in San Marino?
Ensure brevity in your answer.  2.31e+13. In the year 2007, what is the difference between the Taxes (in $) in Belarus and Taxes (in $) in Sao Tome and Principe?
Keep it short and to the point. 2.27e+13. In the year 2007, what is the difference between the Taxes (in $) of Germany and Taxes (in $) of San Marino?
Keep it short and to the point. 2.79e+11. In the year 2007, what is the difference between the Taxes (in $) of Germany and Taxes (in $) of Sao Tome and Principe?
Ensure brevity in your answer.  -4.08e+1. In the year 2007, what is the difference between the Taxes (in $) in San Marino and Taxes (in $) in Sao Tome and Principe?
Your answer should be very brief. -3.19e+11. In the year 2008, what is the difference between the Taxes (in $) of Belarus and Taxes (in $) of Germany?
Provide a succinct answer. 3.26e+13. In the year 2008, what is the difference between the Taxes (in $) of Belarus and Taxes (in $) of San Marino?
Keep it short and to the point. 3.29e+13. In the year 2008, what is the difference between the Taxes (in $) of Belarus and Taxes (in $) of Sao Tome and Principe?
Ensure brevity in your answer.  3.25e+13. In the year 2008, what is the difference between the Taxes (in $) of Germany and Taxes (in $) of San Marino?
Provide a succinct answer. 2.86e+11. In the year 2008, what is the difference between the Taxes (in $) in Germany and Taxes (in $) in Sao Tome and Principe?
Make the answer very short. -1.25e+11. In the year 2008, what is the difference between the Taxes (in $) in San Marino and Taxes (in $) in Sao Tome and Principe?
Your response must be concise. -4.11e+11. In the year 2009, what is the difference between the Taxes (in $) of Belarus and Taxes (in $) of Germany?
Your response must be concise. 2.62e+13. In the year 2009, what is the difference between the Taxes (in $) in Belarus and Taxes (in $) in San Marino?
Your response must be concise. 2.65e+13. In the year 2009, what is the difference between the Taxes (in $) in Belarus and Taxes (in $) in Sao Tome and Principe?
Provide a short and direct response. 2.60e+13. In the year 2009, what is the difference between the Taxes (in $) of Germany and Taxes (in $) of San Marino?
Your answer should be very brief. 2.82e+11. In the year 2009, what is the difference between the Taxes (in $) in Germany and Taxes (in $) in Sao Tome and Principe?
Provide a short and direct response. -1.79e+11. In the year 2009, what is the difference between the Taxes (in $) of San Marino and Taxes (in $) of Sao Tome and Principe?
Offer a very short reply. -4.61e+11. What is the ratio of the Taxes (in $) of Belarus in 2003 to that in 2004?
Your answer should be very brief. 0.7. What is the ratio of the Taxes (in $) in Germany in 2003 to that in 2004?
Ensure brevity in your answer.  1.02. What is the ratio of the Taxes (in $) of San Marino in 2003 to that in 2004?
Offer a terse response. 1. What is the ratio of the Taxes (in $) in Sao Tome and Principe in 2003 to that in 2004?
Provide a short and direct response. 0.74. What is the ratio of the Taxes (in $) in Belarus in 2003 to that in 2005?
Give a very brief answer. 0.49. What is the ratio of the Taxes (in $) of San Marino in 2003 to that in 2005?
Ensure brevity in your answer.  0.9. What is the ratio of the Taxes (in $) in Sao Tome and Principe in 2003 to that in 2005?
Offer a very short reply. 0.66. What is the ratio of the Taxes (in $) of Belarus in 2003 to that in 2006?
Your answer should be very brief. 0.37. What is the ratio of the Taxes (in $) in Germany in 2003 to that in 2006?
Your response must be concise. 0.93. What is the ratio of the Taxes (in $) of San Marino in 2003 to that in 2006?
Your answer should be compact. 0.83. What is the ratio of the Taxes (in $) in Sao Tome and Principe in 2003 to that in 2006?
Provide a short and direct response. 0.36. What is the ratio of the Taxes (in $) in Belarus in 2003 to that in 2007?
Ensure brevity in your answer.  0.28. What is the ratio of the Taxes (in $) in Germany in 2003 to that in 2007?
Offer a terse response. 0.85. What is the ratio of the Taxes (in $) in San Marino in 2003 to that in 2007?
Ensure brevity in your answer.  0.78. What is the ratio of the Taxes (in $) in Sao Tome and Principe in 2003 to that in 2007?
Offer a very short reply. 0.3. What is the ratio of the Taxes (in $) of Belarus in 2003 to that in 2008?
Offer a very short reply. 0.2. What is the ratio of the Taxes (in $) in Germany in 2003 to that in 2008?
Offer a terse response. 0.83. What is the ratio of the Taxes (in $) of San Marino in 2003 to that in 2008?
Ensure brevity in your answer.  0.76. What is the ratio of the Taxes (in $) in Sao Tome and Principe in 2003 to that in 2008?
Offer a terse response. 0.23. What is the ratio of the Taxes (in $) of Belarus in 2003 to that in 2009?
Make the answer very short. 0.24. What is the ratio of the Taxes (in $) of Germany in 2003 to that in 2009?
Offer a very short reply. 0.84. What is the ratio of the Taxes (in $) of San Marino in 2003 to that in 2009?
Your answer should be very brief. 0.87. What is the ratio of the Taxes (in $) in Sao Tome and Principe in 2003 to that in 2009?
Offer a terse response. 0.21. What is the ratio of the Taxes (in $) of Belarus in 2004 to that in 2005?
Give a very brief answer. 0.7. What is the ratio of the Taxes (in $) of Germany in 2004 to that in 2005?
Your answer should be very brief. 0.97. What is the ratio of the Taxes (in $) of San Marino in 2004 to that in 2005?
Keep it short and to the point. 0.9. What is the ratio of the Taxes (in $) in Sao Tome and Principe in 2004 to that in 2005?
Keep it short and to the point. 0.89. What is the ratio of the Taxes (in $) of Belarus in 2004 to that in 2006?
Give a very brief answer. 0.52. What is the ratio of the Taxes (in $) of Germany in 2004 to that in 2006?
Offer a very short reply. 0.91. What is the ratio of the Taxes (in $) of San Marino in 2004 to that in 2006?
Make the answer very short. 0.84. What is the ratio of the Taxes (in $) of Sao Tome and Principe in 2004 to that in 2006?
Provide a succinct answer. 0.49. What is the ratio of the Taxes (in $) in Belarus in 2004 to that in 2007?
Your answer should be compact. 0.4. What is the ratio of the Taxes (in $) in Germany in 2004 to that in 2007?
Your response must be concise. 0.83. What is the ratio of the Taxes (in $) of San Marino in 2004 to that in 2007?
Offer a terse response. 0.78. What is the ratio of the Taxes (in $) in Sao Tome and Principe in 2004 to that in 2007?
Your answer should be very brief. 0.41. What is the ratio of the Taxes (in $) in Belarus in 2004 to that in 2008?
Offer a very short reply. 0.28. What is the ratio of the Taxes (in $) in Germany in 2004 to that in 2008?
Make the answer very short. 0.81. What is the ratio of the Taxes (in $) in San Marino in 2004 to that in 2008?
Offer a very short reply. 0.76. What is the ratio of the Taxes (in $) in Sao Tome and Principe in 2004 to that in 2008?
Offer a terse response. 0.32. What is the ratio of the Taxes (in $) of Belarus in 2004 to that in 2009?
Your answer should be compact. 0.35. What is the ratio of the Taxes (in $) in Germany in 2004 to that in 2009?
Make the answer very short. 0.82. What is the ratio of the Taxes (in $) in San Marino in 2004 to that in 2009?
Provide a short and direct response. 0.88. What is the ratio of the Taxes (in $) in Sao Tome and Principe in 2004 to that in 2009?
Offer a very short reply. 0.28. What is the ratio of the Taxes (in $) in Belarus in 2005 to that in 2006?
Your answer should be very brief. 0.74. What is the ratio of the Taxes (in $) of Germany in 2005 to that in 2006?
Offer a terse response. 0.94. What is the ratio of the Taxes (in $) in San Marino in 2005 to that in 2006?
Ensure brevity in your answer.  0.93. What is the ratio of the Taxes (in $) of Sao Tome and Principe in 2005 to that in 2006?
Offer a very short reply. 0.55. What is the ratio of the Taxes (in $) of Belarus in 2005 to that in 2007?
Offer a very short reply. 0.57. What is the ratio of the Taxes (in $) of Germany in 2005 to that in 2007?
Your response must be concise. 0.86. What is the ratio of the Taxes (in $) in San Marino in 2005 to that in 2007?
Provide a short and direct response. 0.86. What is the ratio of the Taxes (in $) of Sao Tome and Principe in 2005 to that in 2007?
Make the answer very short. 0.46. What is the ratio of the Taxes (in $) in Belarus in 2005 to that in 2008?
Offer a terse response. 0.4. What is the ratio of the Taxes (in $) in Germany in 2005 to that in 2008?
Keep it short and to the point. 0.84. What is the ratio of the Taxes (in $) in San Marino in 2005 to that in 2008?
Keep it short and to the point. 0.84. What is the ratio of the Taxes (in $) in Sao Tome and Principe in 2005 to that in 2008?
Offer a very short reply. 0.35. What is the ratio of the Taxes (in $) of Belarus in 2005 to that in 2009?
Make the answer very short. 0.5. What is the ratio of the Taxes (in $) in Germany in 2005 to that in 2009?
Offer a very short reply. 0.85. What is the ratio of the Taxes (in $) in Sao Tome and Principe in 2005 to that in 2009?
Give a very brief answer. 0.32. What is the ratio of the Taxes (in $) in Belarus in 2006 to that in 2007?
Make the answer very short. 0.76. What is the ratio of the Taxes (in $) in Germany in 2006 to that in 2007?
Offer a terse response. 0.91. What is the ratio of the Taxes (in $) of Sao Tome and Principe in 2006 to that in 2007?
Offer a terse response. 0.83. What is the ratio of the Taxes (in $) in Belarus in 2006 to that in 2008?
Make the answer very short. 0.54. What is the ratio of the Taxes (in $) in Germany in 2006 to that in 2008?
Your response must be concise. 0.89. What is the ratio of the Taxes (in $) in San Marino in 2006 to that in 2008?
Offer a terse response. 0.91. What is the ratio of the Taxes (in $) of Sao Tome and Principe in 2006 to that in 2008?
Offer a very short reply. 0.65. What is the ratio of the Taxes (in $) of Belarus in 2006 to that in 2009?
Provide a succinct answer. 0.67. What is the ratio of the Taxes (in $) in Germany in 2006 to that in 2009?
Your answer should be very brief. 0.9. What is the ratio of the Taxes (in $) in San Marino in 2006 to that in 2009?
Provide a succinct answer. 1.04. What is the ratio of the Taxes (in $) of Sao Tome and Principe in 2006 to that in 2009?
Provide a short and direct response. 0.58. What is the ratio of the Taxes (in $) of Belarus in 2007 to that in 2008?
Provide a short and direct response. 0.7. What is the ratio of the Taxes (in $) of Germany in 2007 to that in 2008?
Keep it short and to the point. 0.98. What is the ratio of the Taxes (in $) of San Marino in 2007 to that in 2008?
Offer a terse response. 0.98. What is the ratio of the Taxes (in $) of Sao Tome and Principe in 2007 to that in 2008?
Offer a terse response. 0.78. What is the ratio of the Taxes (in $) of Belarus in 2007 to that in 2009?
Your answer should be very brief. 0.87. What is the ratio of the Taxes (in $) of San Marino in 2007 to that in 2009?
Your answer should be compact. 1.12. What is the ratio of the Taxes (in $) of Sao Tome and Principe in 2007 to that in 2009?
Offer a very short reply. 0.69. What is the ratio of the Taxes (in $) of Belarus in 2008 to that in 2009?
Your answer should be very brief. 1.24. What is the ratio of the Taxes (in $) of Germany in 2008 to that in 2009?
Give a very brief answer. 1.01. What is the ratio of the Taxes (in $) of San Marino in 2008 to that in 2009?
Provide a succinct answer. 1.15. What is the ratio of the Taxes (in $) of Sao Tome and Principe in 2008 to that in 2009?
Your response must be concise. 0.89. What is the difference between the highest and the second highest Taxes (in $) in Belarus?
Ensure brevity in your answer.  6.44e+12. What is the difference between the highest and the second highest Taxes (in $) of Germany?
Ensure brevity in your answer.  3.58e+09. What is the difference between the highest and the second highest Taxes (in $) of San Marino?
Give a very brief answer. 7.06e+06. What is the difference between the highest and the second highest Taxes (in $) of Sao Tome and Principe?
Offer a terse response. 5.06e+1. What is the difference between the highest and the lowest Taxes (in $) of Belarus?
Provide a short and direct response. 2.64e+13. What is the difference between the highest and the lowest Taxes (in $) in Germany?
Offer a terse response. 5.30e+1. What is the difference between the highest and the lowest Taxes (in $) in San Marino?
Make the answer very short. 7.02e+07. What is the difference between the highest and the lowest Taxes (in $) of Sao Tome and Principe?
Offer a very short reply. 3.66e+11. 